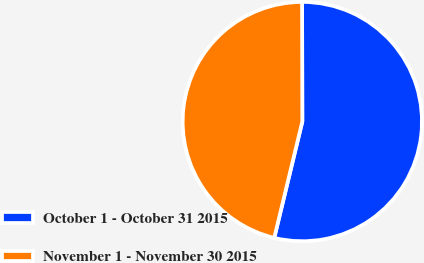<chart> <loc_0><loc_0><loc_500><loc_500><pie_chart><fcel>October 1 - October 31 2015<fcel>November 1 - November 30 2015<nl><fcel>53.8%<fcel>46.2%<nl></chart> 